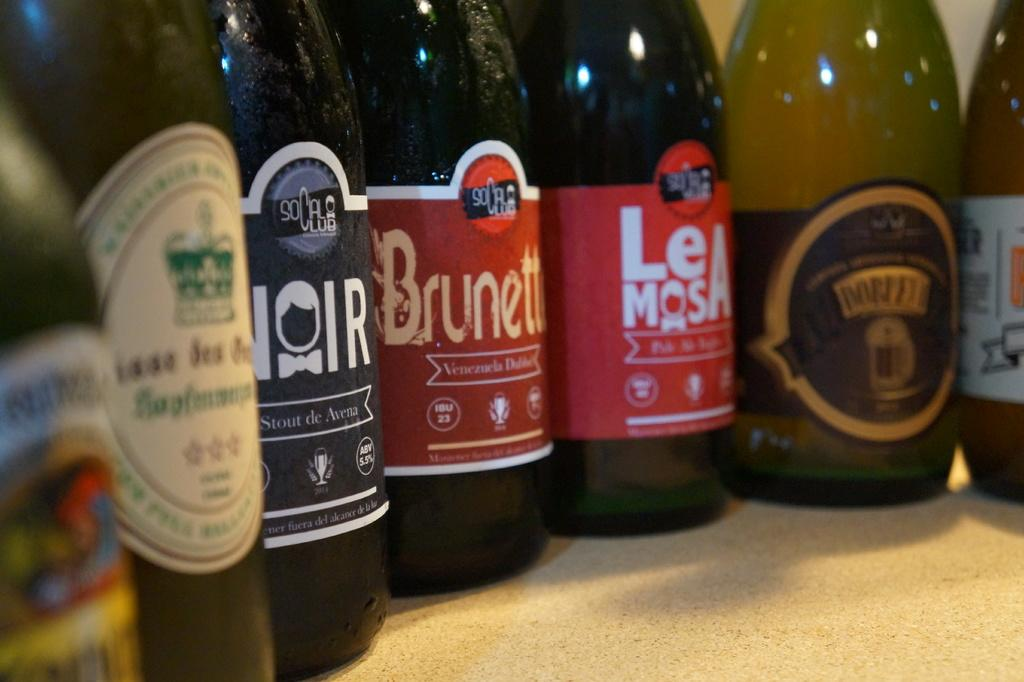<image>
Relay a brief, clear account of the picture shown. Seven different kinds of drinks are sitting in a semi circle with one being Brunet and Le mosa. 